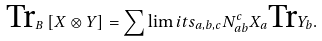<formula> <loc_0><loc_0><loc_500><loc_500>\text {Tr} _ { B } \left [ X \otimes Y \right ] = \sum \lim i t s _ { a , b , c } N _ { a b } ^ { c } X _ { a } \text {Tr} Y _ { b } .</formula> 